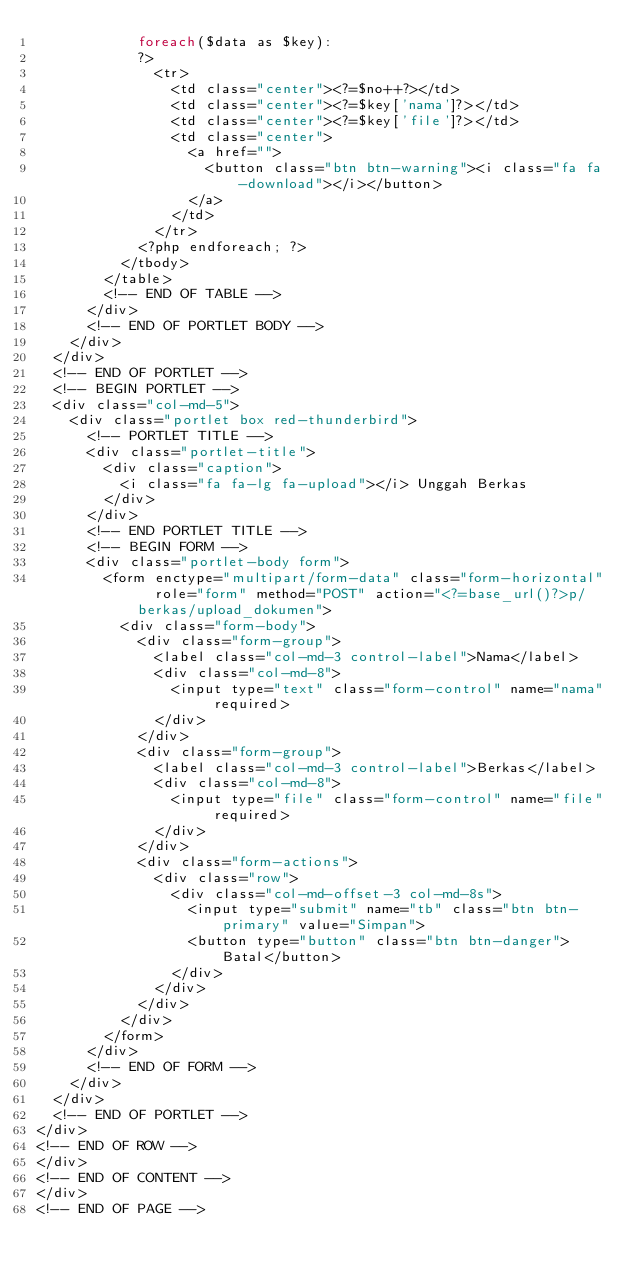Convert code to text. <code><loc_0><loc_0><loc_500><loc_500><_PHP_>            foreach($data as $key):
            ?>
              <tr>
                <td class="center"><?=$no++?></td>
                <td class="center"><?=$key['nama']?></td>
                <td class="center"><?=$key['file']?></td>
                <td class="center">
                  <a href="">
                    <button class="btn btn-warning"><i class="fa fa-download"></i></button>
                  </a>
                </td>
              </tr>
            <?php endforeach; ?>
          </tbody>
        </table>
        <!-- END OF TABLE -->
      </div>
      <!-- END OF PORTLET BODY -->
    </div>
  </div>
  <!-- END OF PORTLET -->
  <!-- BEGIN PORTLET -->
  <div class="col-md-5">
    <div class="portlet box red-thunderbird">
      <!-- PORTLET TITLE -->
      <div class="portlet-title">
        <div class="caption">
          <i class="fa fa-lg fa-upload"></i> Unggah Berkas
        </div>
      </div>
      <!-- END PORTLET TITLE -->
      <!-- BEGIN FORM -->
      <div class="portlet-body form">
        <form enctype="multipart/form-data" class="form-horizontal"  role="form" method="POST" action="<?=base_url()?>p/berkas/upload_dokumen">
          <div class="form-body">
            <div class="form-group">
              <label class="col-md-3 control-label">Nama</label>
              <div class="col-md-8">
                <input type="text" class="form-control" name="nama" required>
              </div>
            </div>
            <div class="form-group">
              <label class="col-md-3 control-label">Berkas</label>
              <div class="col-md-8">
                <input type="file" class="form-control" name="file" required>
              </div>
            </div>
            <div class="form-actions">
              <div class="row">
                <div class="col-md-offset-3 col-md-8s">
                  <input type="submit" name="tb" class="btn btn-primary" value="Simpan">
                  <button type="button" class="btn btn-danger">Batal</button>
                </div>
              </div>
            </div>
          </div>
        </form>
      </div>
      <!-- END OF FORM -->
    </div>
  </div>
  <!-- END OF PORTLET -->
</div>
<!-- END OF ROW -->
</div>
<!-- END OF CONTENT -->
</div>
<!-- END OF PAGE -->
</code> 